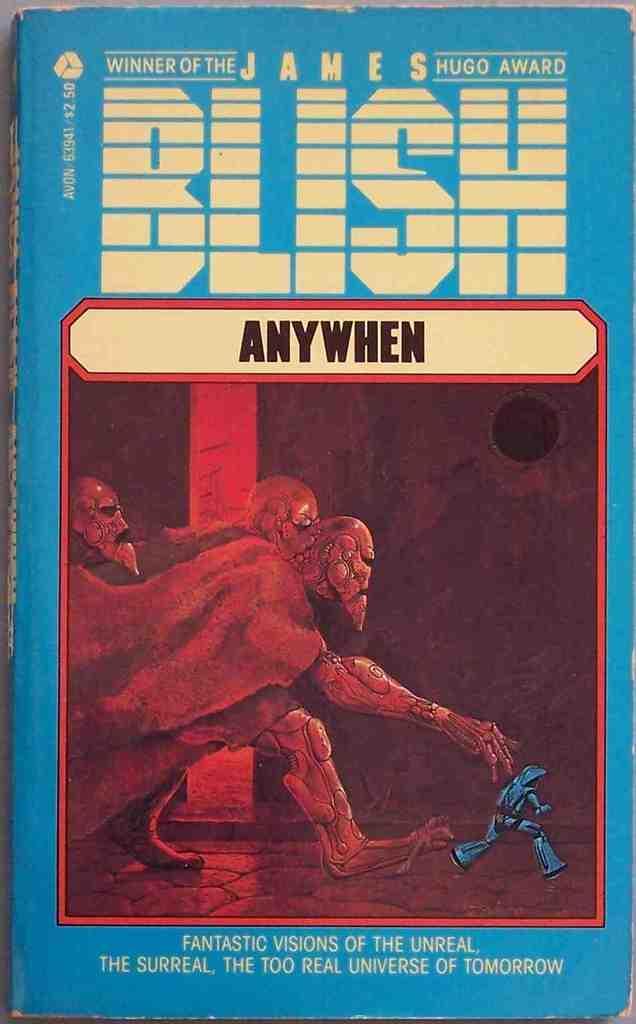In one or two sentences, can you explain what this image depicts? In this picture we can see cover page of a book on which there are some animated images and there is some text. 